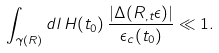Convert formula to latex. <formula><loc_0><loc_0><loc_500><loc_500>\int _ { \gamma ( R ) } d l \, H ( t _ { 0 } ) \, \frac { \left | \Delta ( R _ { , t } \epsilon ) \right | } { \epsilon _ { c } ( t _ { 0 } ) } \ll 1 .</formula> 